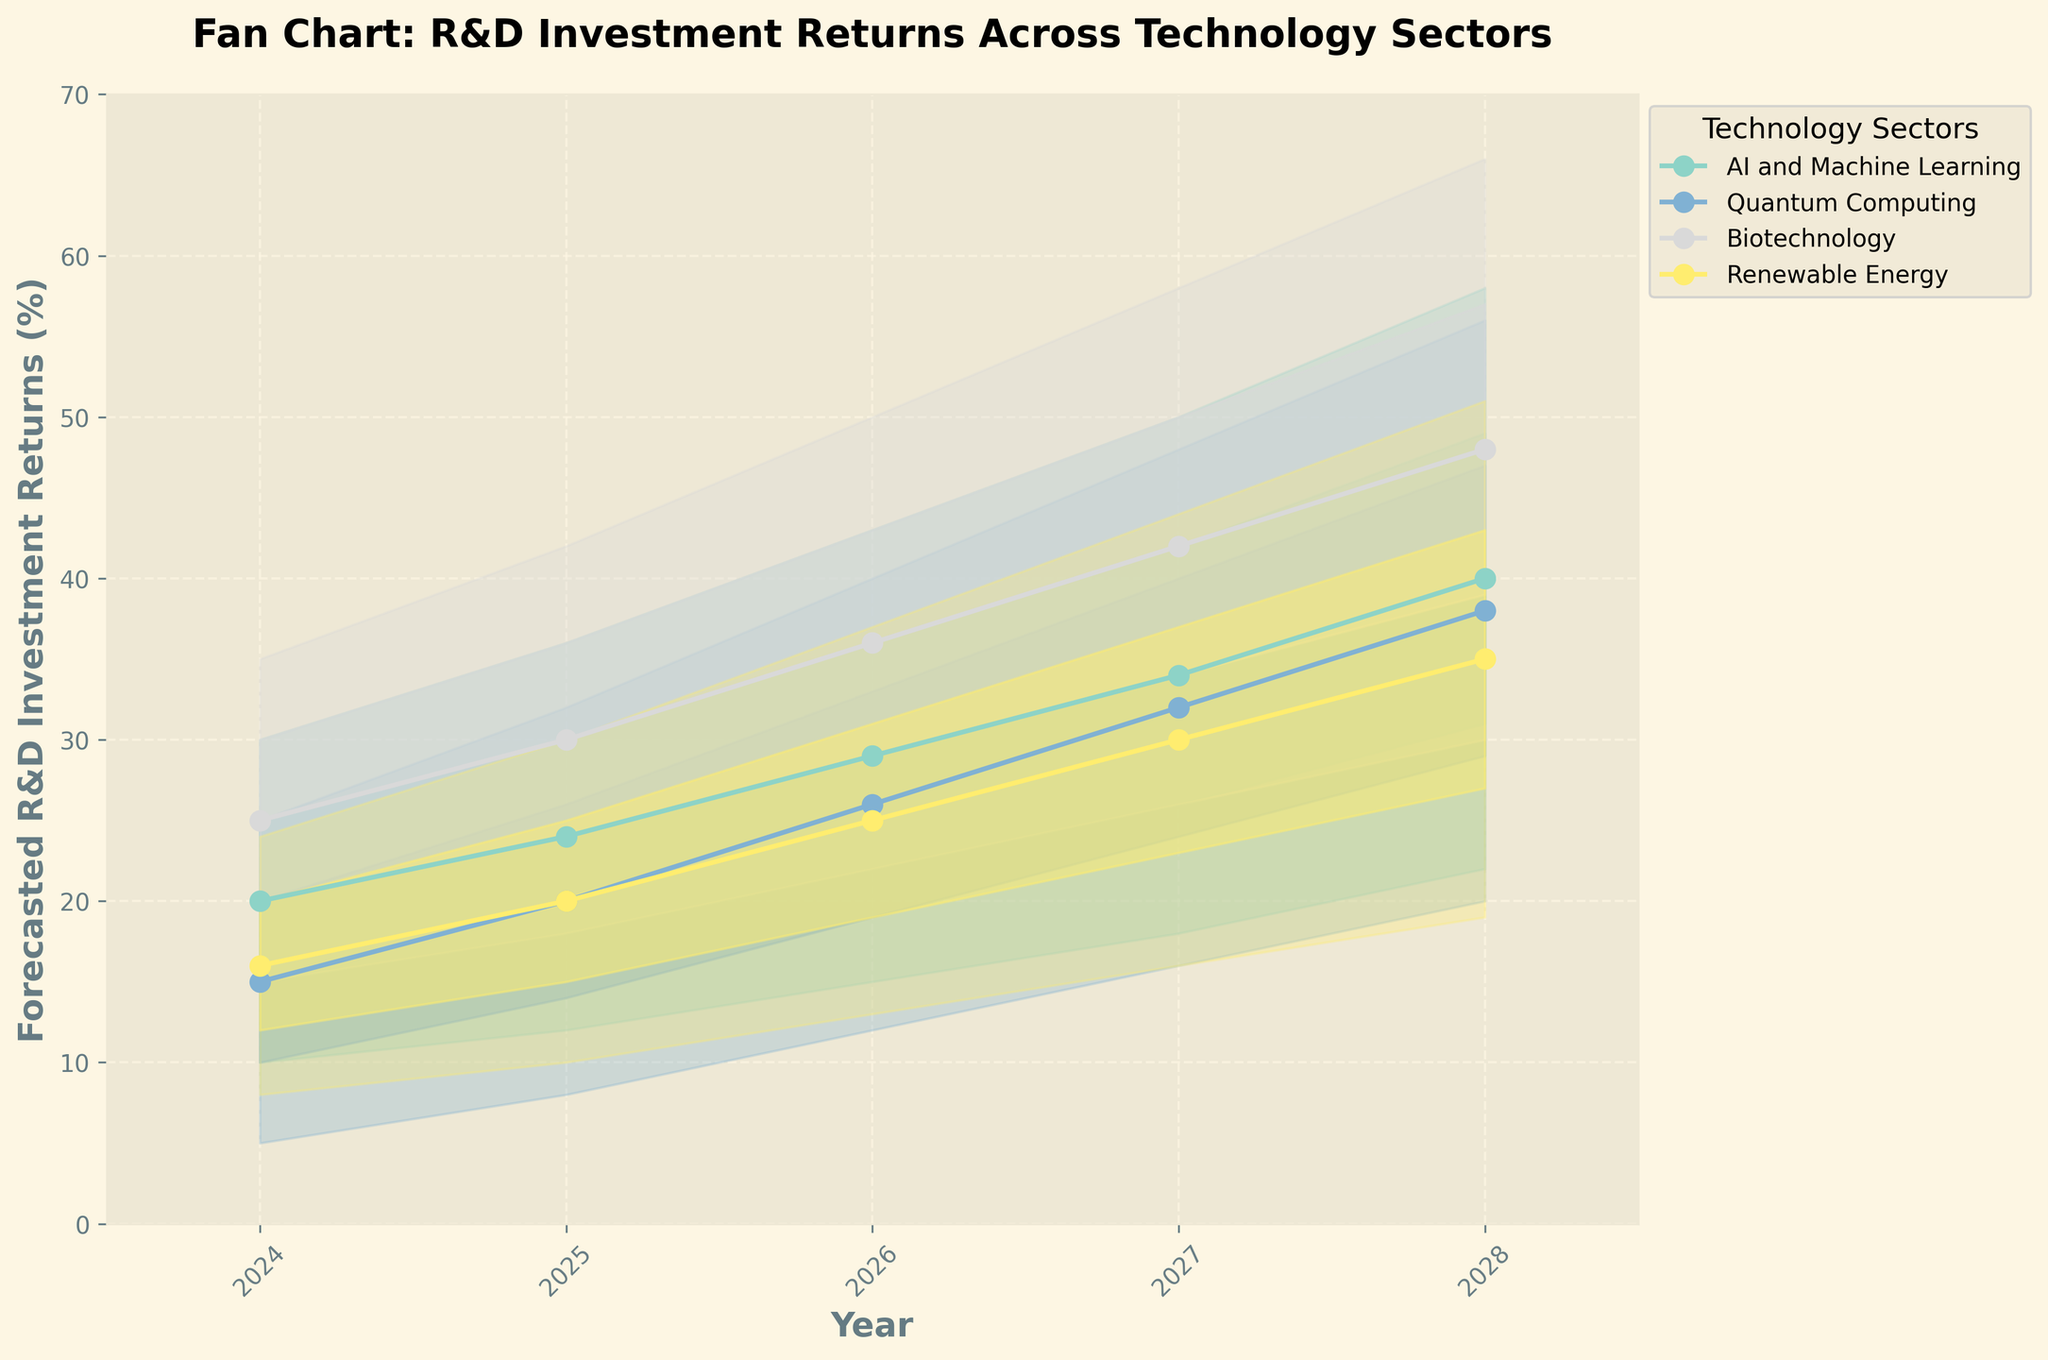What's the time range shown in the figure? The x-axis represents the time, labeled as "Year." From the labels on the x-axis, the years range from 2024 to 2028.
Answer: 2024 to 2028 Which sector has the highest forecasted return in 2028 according to the median value? By looking at the plot, the median value for each sector is marked with a line and plotted points. In 2028, Biotechnology has the highest median value as its line is the highest point on the y-axis compared to other sectors.
Answer: Biotechnology How does the forecasted median return for Quantum Computing change from 2024 to 2028? Locate Quantum Computing's line on the plot and check its median values. In 2024, it's 15%, and in 2028, it's 38%. The increase is 38% - 15% = 23%.
Answer: It increases by 23 percentage points Which sector shows the least variability in forecasted returns in 2025? Variability can be assessed by the width of the shaded area (representing ranges of values) at each point. In 2025, Renewable Energy has the smallest width between its high and low values compared to other sectors.
Answer: Renewable Energy Is there any sector expected to have a consistent increase in median returns year over year? Check the median lines for any sector that consistently move upward each year. AI and Machine Learning, Quantum Computing, Biotechnology, and Renewable Energy all show consistent increases in median returns each year.
Answer: Yes, all sectors Between 2024 and 2027, which sector has the largest absolute change in the lowest forecasted return? Find the absolute change by subtracting the lowest value in 2024 from the lowest value in 2027 for each sector. For AI and Machine Learning, it's 18-10=8; Quantum Computing is 16-5=11; Biotechnology is 26-15=11; Renewable Energy is 16-8=8. Quantum Computing and Biotechnology each have the largest change of 11.
Answer: Quantum Computing and Biotechnology How does the variability in forecasted returns for AI and Machine Learning change from 2024 to 2028? Check the width of the shaded area for AI and Machine Learning from 2024 to 2028. In 2024, the range is 30-10=20; in 2028, it's 58-22=36. The variability increases by 36-20=16.
Answer: It increases by 16 percentage points Which sector is expected to have the highest forecasted upper bound return in 2026? Locate the high value for each sector in 2026. Biotechnology has the highest upper bound value at 50%, more than any other sector.
Answer: Biotechnology For Biotechnology, what is the percentage point difference between the median and the low-mid range in 2025? In 2025, the median for Biotechnology is 30%, and the low-mid range value is 24%. The difference is 30 - 24 = 6 percentage points.
Answer: 6 percentage points 